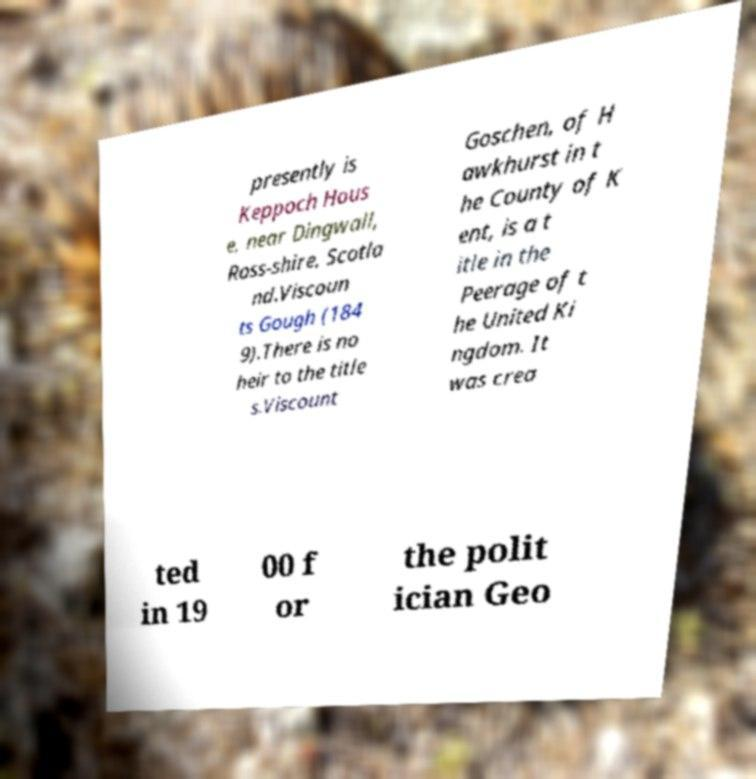What messages or text are displayed in this image? I need them in a readable, typed format. presently is Keppoch Hous e, near Dingwall, Ross-shire, Scotla nd.Viscoun ts Gough (184 9).There is no heir to the title s.Viscount Goschen, of H awkhurst in t he County of K ent, is a t itle in the Peerage of t he United Ki ngdom. It was crea ted in 19 00 f or the polit ician Geo 